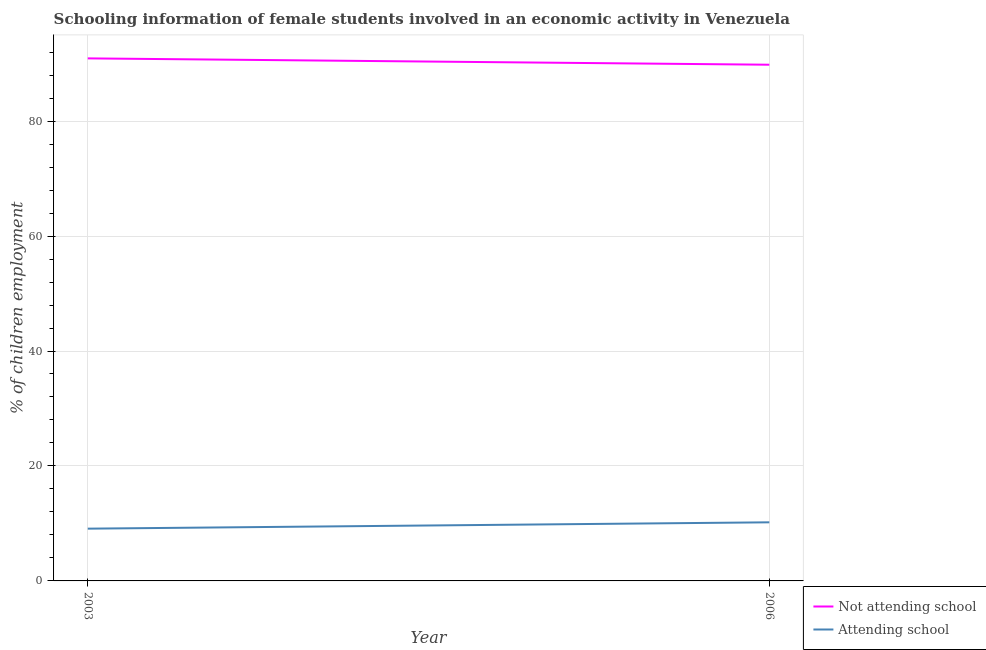What is the percentage of employed females who are attending school in 2003?
Provide a short and direct response. 9.09. Across all years, what is the maximum percentage of employed females who are not attending school?
Offer a terse response. 90.91. Across all years, what is the minimum percentage of employed females who are attending school?
Keep it short and to the point. 9.09. In which year was the percentage of employed females who are not attending school maximum?
Your answer should be very brief. 2003. In which year was the percentage of employed females who are attending school minimum?
Offer a very short reply. 2003. What is the total percentage of employed females who are not attending school in the graph?
Provide a succinct answer. 180.72. What is the difference between the percentage of employed females who are not attending school in 2003 and that in 2006?
Your answer should be very brief. 1.1. What is the difference between the percentage of employed females who are not attending school in 2006 and the percentage of employed females who are attending school in 2003?
Make the answer very short. 80.72. What is the average percentage of employed females who are attending school per year?
Keep it short and to the point. 9.64. In the year 2006, what is the difference between the percentage of employed females who are attending school and percentage of employed females who are not attending school?
Your answer should be compact. -79.61. What is the ratio of the percentage of employed females who are attending school in 2003 to that in 2006?
Offer a very short reply. 0.89. In how many years, is the percentage of employed females who are not attending school greater than the average percentage of employed females who are not attending school taken over all years?
Your response must be concise. 1. Does the percentage of employed females who are attending school monotonically increase over the years?
Make the answer very short. Yes. How many lines are there?
Make the answer very short. 2. How many years are there in the graph?
Ensure brevity in your answer.  2. What is the difference between two consecutive major ticks on the Y-axis?
Make the answer very short. 20. Does the graph contain grids?
Offer a terse response. Yes. Where does the legend appear in the graph?
Your answer should be compact. Bottom right. How many legend labels are there?
Your answer should be very brief. 2. What is the title of the graph?
Ensure brevity in your answer.  Schooling information of female students involved in an economic activity in Venezuela. What is the label or title of the Y-axis?
Give a very brief answer. % of children employment. What is the % of children employment of Not attending school in 2003?
Provide a succinct answer. 90.91. What is the % of children employment of Attending school in 2003?
Give a very brief answer. 9.09. What is the % of children employment of Not attending school in 2006?
Your response must be concise. 89.81. What is the % of children employment in Attending school in 2006?
Make the answer very short. 10.19. Across all years, what is the maximum % of children employment of Not attending school?
Provide a succinct answer. 90.91. Across all years, what is the maximum % of children employment in Attending school?
Your response must be concise. 10.19. Across all years, what is the minimum % of children employment in Not attending school?
Your answer should be very brief. 89.81. Across all years, what is the minimum % of children employment of Attending school?
Keep it short and to the point. 9.09. What is the total % of children employment in Not attending school in the graph?
Provide a short and direct response. 180.72. What is the total % of children employment in Attending school in the graph?
Your response must be concise. 19.29. What is the difference between the % of children employment of Not attending school in 2003 and that in 2006?
Ensure brevity in your answer.  1.1. What is the difference between the % of children employment in Attending school in 2003 and that in 2006?
Keep it short and to the point. -1.1. What is the difference between the % of children employment of Not attending school in 2003 and the % of children employment of Attending school in 2006?
Keep it short and to the point. 80.72. What is the average % of children employment in Not attending school per year?
Make the answer very short. 90.36. What is the average % of children employment in Attending school per year?
Provide a succinct answer. 9.64. In the year 2003, what is the difference between the % of children employment of Not attending school and % of children employment of Attending school?
Ensure brevity in your answer.  81.82. In the year 2006, what is the difference between the % of children employment in Not attending school and % of children employment in Attending school?
Provide a succinct answer. 79.61. What is the ratio of the % of children employment in Not attending school in 2003 to that in 2006?
Your response must be concise. 1.01. What is the ratio of the % of children employment of Attending school in 2003 to that in 2006?
Your answer should be compact. 0.89. What is the difference between the highest and the second highest % of children employment of Not attending school?
Ensure brevity in your answer.  1.1. What is the difference between the highest and the second highest % of children employment of Attending school?
Offer a terse response. 1.1. What is the difference between the highest and the lowest % of children employment in Not attending school?
Offer a very short reply. 1.1. What is the difference between the highest and the lowest % of children employment in Attending school?
Your response must be concise. 1.1. 